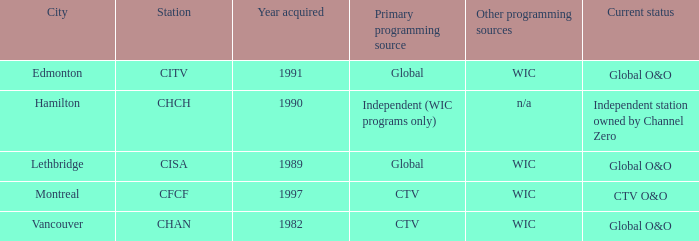What constitutes the minimum for citv? 1991.0. 